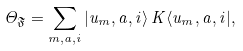Convert formula to latex. <formula><loc_0><loc_0><loc_500><loc_500>\Theta _ { \mathfrak { F } } = \sum _ { m , a , i } \left | u _ { m } , a , i \right \rangle K \langle u _ { m } , a , i | ,</formula> 